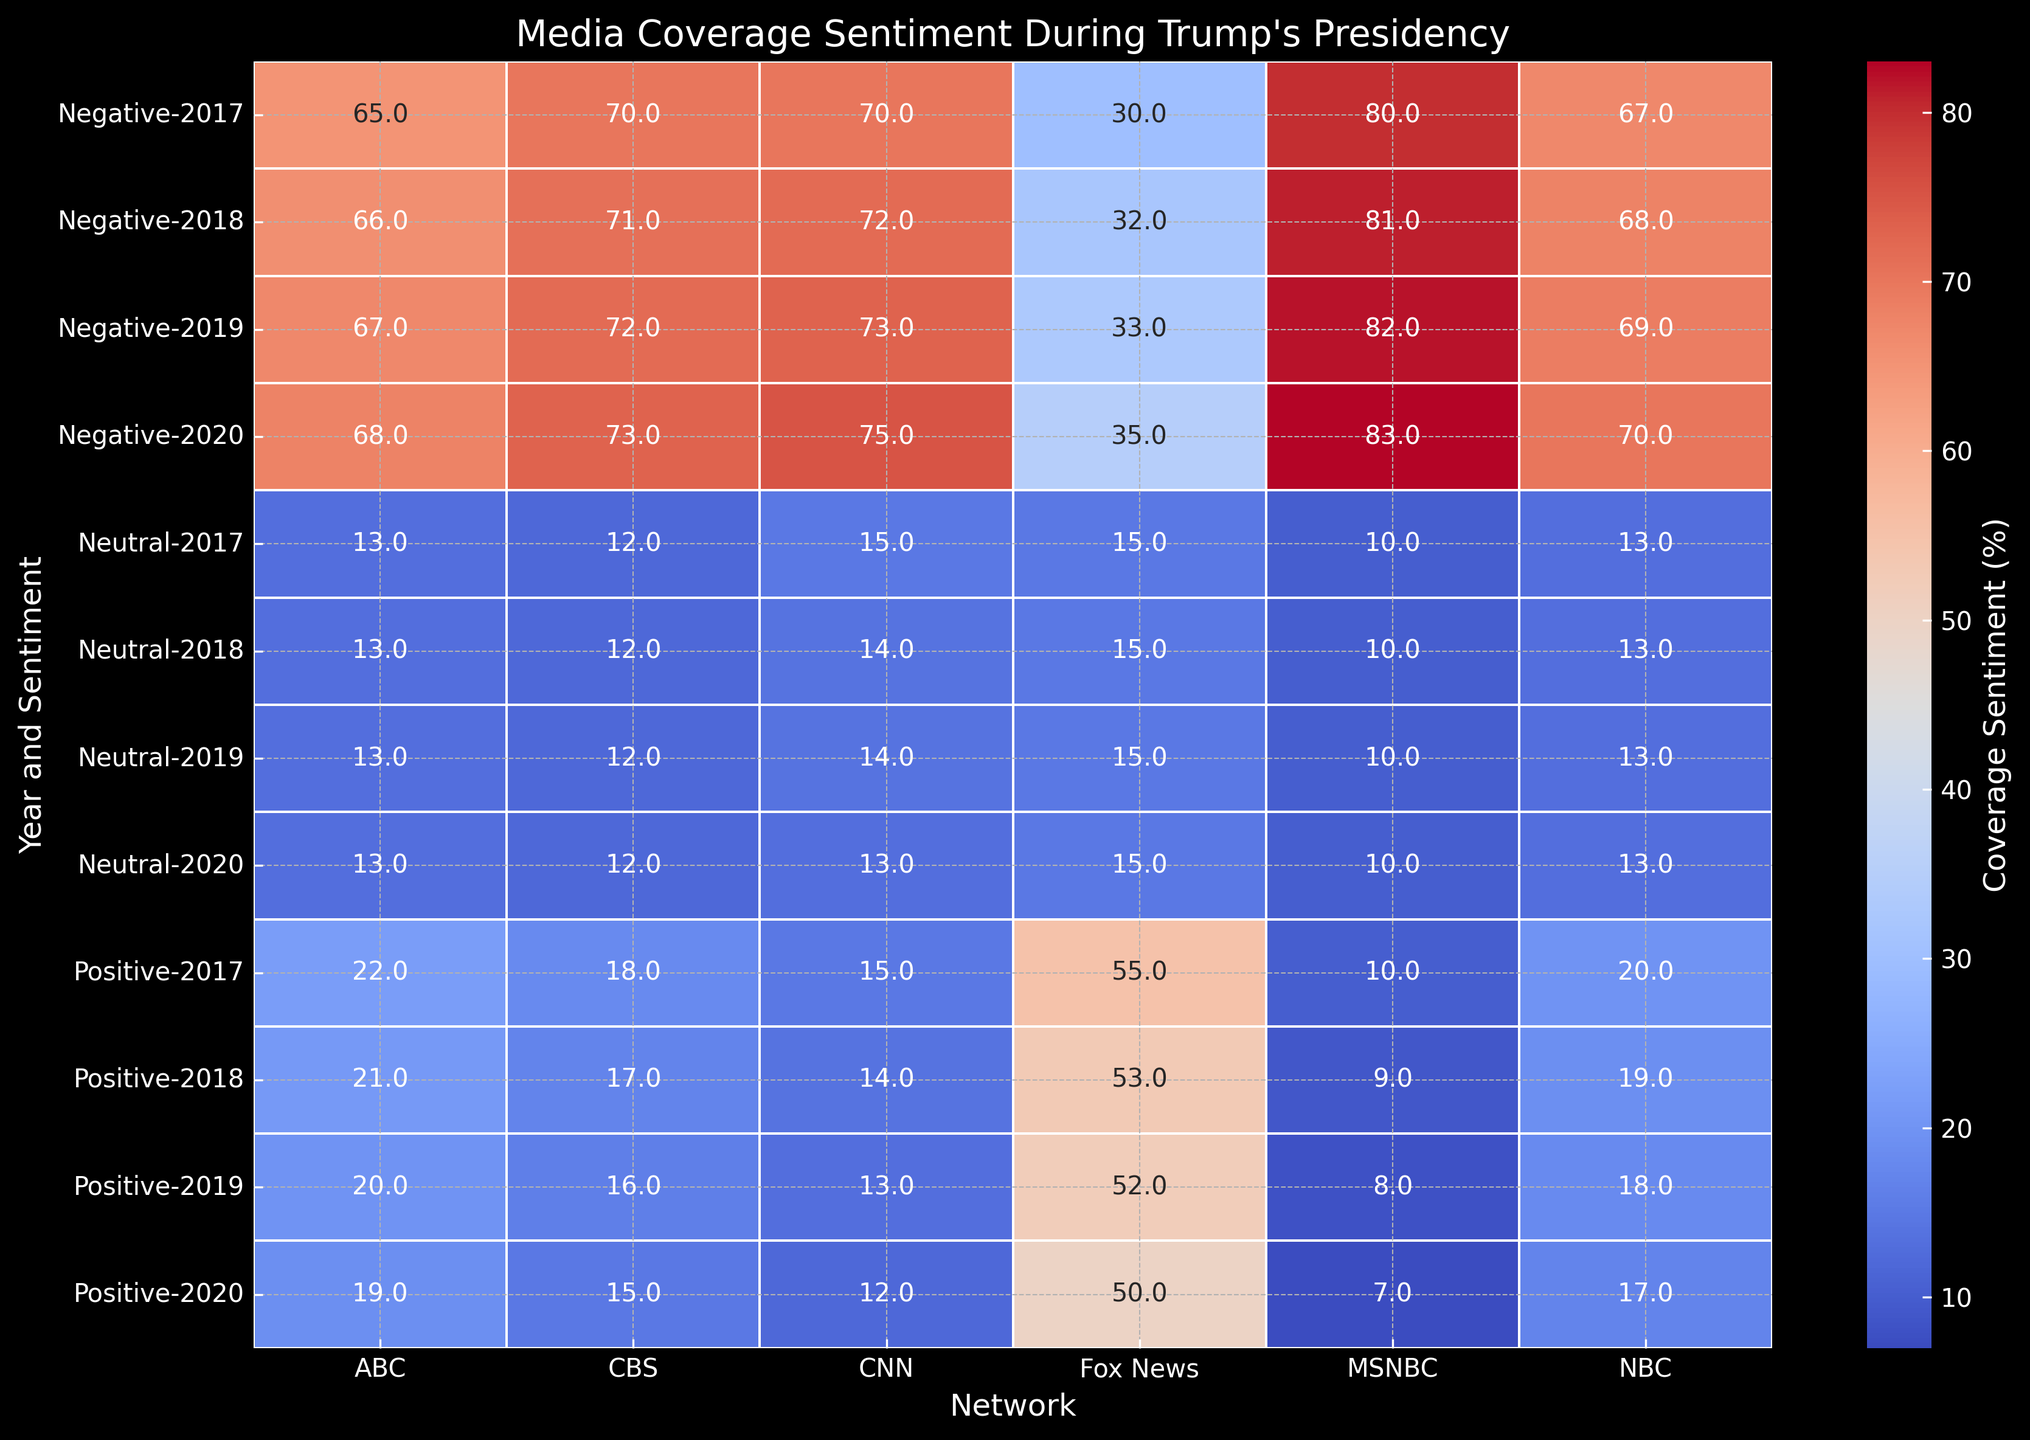What's the average negative sentiment for MSNBC across all years? Sum the negative sentiments for MSNBC from 2017 to 2020 and then divide by the number of years. (80 + 81 + 82 + 83) / 4 = 81.5
Answer: 81.5 Which network had the highest positive sentiment in 2017? Compare the positive sentiment values of all networks for the year 2017 and identify the highest. Highest positive sentiment in 2017 is 55 on Fox News.
Answer: Fox News Is the trend of positive sentiment increasing or decreasing for CNN from 2017 to 2020? Look at the positive sentiment values of CNN from 2017 to 2020. The values are 15, 14, 13, and 12, which shows a consistent decrease.
Answer: Decreasing Between CNN and MSNBC, which network had a higher neutral sentiment in 2019? Compare the neutral sentiment values of CNN and MSNBC for the year 2019. CNN had 14 and MSNBC had 10. Thus, CNN had a higher neutral sentiment.
Answer: CNN Which year had the most negative sentiment for ABC? Compare the negative sentiment values of ABC across 2017, 2018, 2019, and 2020. The values are 65, 66, 67, and 68 respectively, so 2020 had the highest negative sentiment.
Answer: 2020 What is the difference in positive sentiment between Fox News and CNN in 2020? Subtract the positive sentiment of CNN from that of Fox News in 2020. Fox News had 50, and CNN had 12, so the difference is 50 - 12 = 38.
Answer: 38 Does NBC's negative sentiment increase or decrease from 2017 to 2020? Look at the negative sentiment values of NBC from 2017 to 2020. The values are 67, 68, 69, and 70, showing an increasing trend.
Answer: Increasing Which network had a consistent neutral sentiment over all four years? Check the neutral sentiment values for each network from 2017 to 2020. Fox News had a consistent neutral sentiment value of 15.
Answer: Fox News Compare the positive sentiment of CBS and ABC in 2018. Which network had a higher value? Look at the positive sentiment values of CBS and ABC for the year 2018. CBS had 17 and ABC had 21. Thus, ABC had a higher positive sentiment.
Answer: ABC How does the negative sentiment trend for MSNBC compare to that of CNN? Look at the negative sentiment values from 2017 to 2020 for both networks. MSNBC shows an increasing trend from 80 to 83, while CNN also shows an increasing trend from 70 to 75. Both networks have an increasing trend, but MSNBC's values are higher.
Answer: Both increased, MSNBC has higher values 